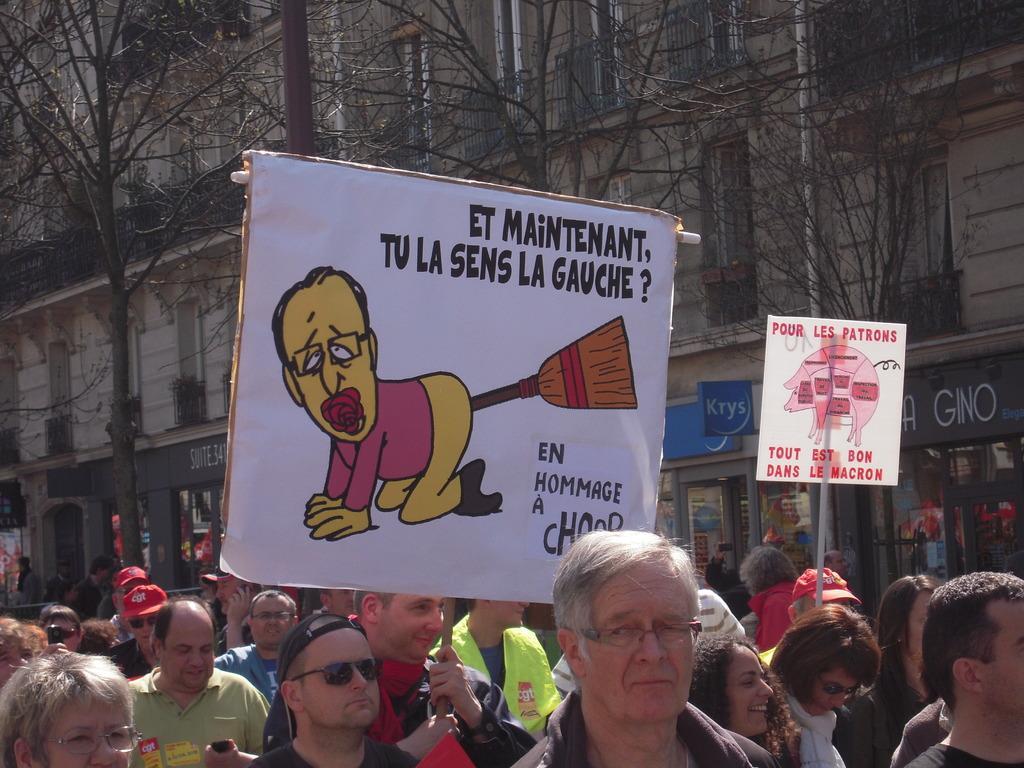Could you give a brief overview of what you see in this image? This image consists of many people. In the middle, there is a man holding a placard. In the background, there are many trees and buildings along with the boards. 